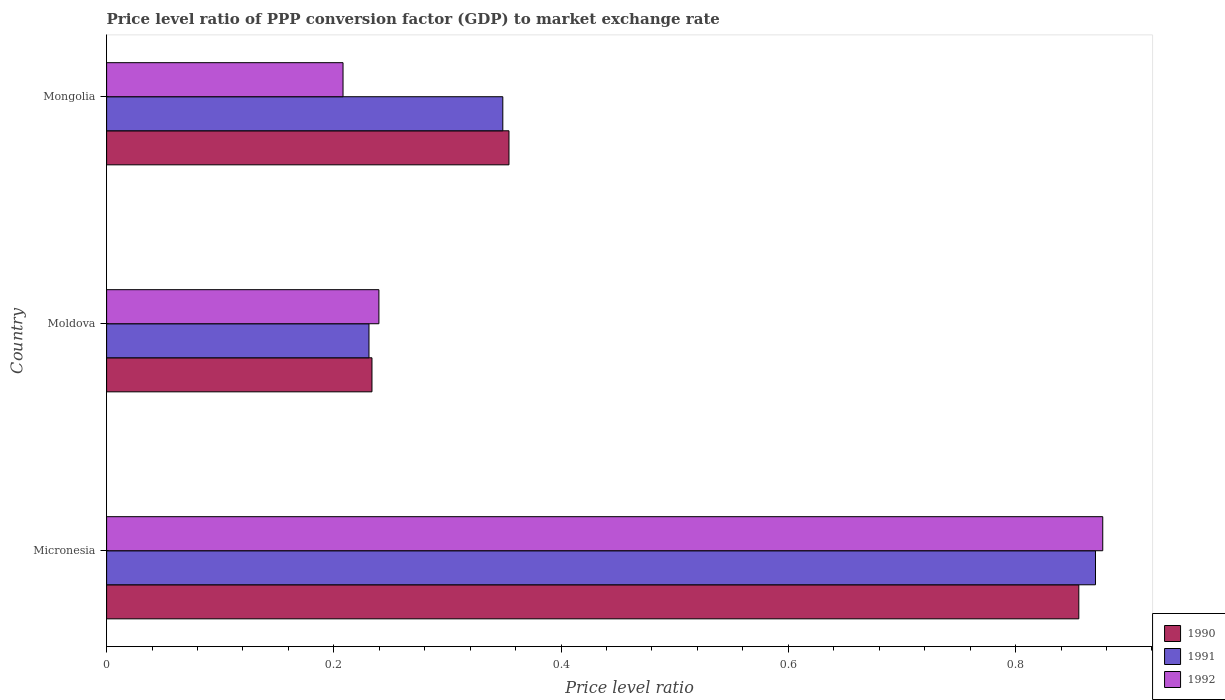How many different coloured bars are there?
Keep it short and to the point. 3. How many groups of bars are there?
Make the answer very short. 3. How many bars are there on the 3rd tick from the bottom?
Offer a very short reply. 3. What is the label of the 1st group of bars from the top?
Keep it short and to the point. Mongolia. In how many cases, is the number of bars for a given country not equal to the number of legend labels?
Your response must be concise. 0. What is the price level ratio in 1992 in Micronesia?
Provide a succinct answer. 0.88. Across all countries, what is the maximum price level ratio in 1992?
Keep it short and to the point. 0.88. Across all countries, what is the minimum price level ratio in 1992?
Your response must be concise. 0.21. In which country was the price level ratio in 1992 maximum?
Keep it short and to the point. Micronesia. In which country was the price level ratio in 1990 minimum?
Keep it short and to the point. Moldova. What is the total price level ratio in 1991 in the graph?
Offer a terse response. 1.45. What is the difference between the price level ratio in 1992 in Micronesia and that in Moldova?
Make the answer very short. 0.64. What is the difference between the price level ratio in 1990 in Moldova and the price level ratio in 1991 in Micronesia?
Keep it short and to the point. -0.64. What is the average price level ratio in 1990 per country?
Your answer should be very brief. 0.48. What is the difference between the price level ratio in 1990 and price level ratio in 1991 in Micronesia?
Provide a succinct answer. -0.01. What is the ratio of the price level ratio in 1990 in Micronesia to that in Mongolia?
Provide a succinct answer. 2.42. Is the price level ratio in 1990 in Micronesia less than that in Moldova?
Keep it short and to the point. No. Is the difference between the price level ratio in 1990 in Moldova and Mongolia greater than the difference between the price level ratio in 1991 in Moldova and Mongolia?
Make the answer very short. No. What is the difference between the highest and the second highest price level ratio in 1990?
Offer a terse response. 0.5. What is the difference between the highest and the lowest price level ratio in 1992?
Ensure brevity in your answer.  0.67. In how many countries, is the price level ratio in 1992 greater than the average price level ratio in 1992 taken over all countries?
Offer a terse response. 1. Is the sum of the price level ratio in 1992 in Micronesia and Mongolia greater than the maximum price level ratio in 1990 across all countries?
Your response must be concise. Yes. What does the 2nd bar from the top in Micronesia represents?
Offer a terse response. 1991. What does the 1st bar from the bottom in Moldova represents?
Offer a terse response. 1990. Is it the case that in every country, the sum of the price level ratio in 1990 and price level ratio in 1992 is greater than the price level ratio in 1991?
Offer a terse response. Yes. Are all the bars in the graph horizontal?
Keep it short and to the point. Yes. How many countries are there in the graph?
Provide a succinct answer. 3. What is the difference between two consecutive major ticks on the X-axis?
Make the answer very short. 0.2. Are the values on the major ticks of X-axis written in scientific E-notation?
Offer a very short reply. No. Does the graph contain grids?
Your response must be concise. No. How many legend labels are there?
Provide a short and direct response. 3. How are the legend labels stacked?
Provide a succinct answer. Vertical. What is the title of the graph?
Your response must be concise. Price level ratio of PPP conversion factor (GDP) to market exchange rate. Does "2011" appear as one of the legend labels in the graph?
Ensure brevity in your answer.  No. What is the label or title of the X-axis?
Offer a terse response. Price level ratio. What is the Price level ratio in 1990 in Micronesia?
Your response must be concise. 0.86. What is the Price level ratio of 1991 in Micronesia?
Offer a terse response. 0.87. What is the Price level ratio in 1992 in Micronesia?
Provide a succinct answer. 0.88. What is the Price level ratio of 1990 in Moldova?
Give a very brief answer. 0.23. What is the Price level ratio in 1991 in Moldova?
Your response must be concise. 0.23. What is the Price level ratio of 1992 in Moldova?
Provide a short and direct response. 0.24. What is the Price level ratio of 1990 in Mongolia?
Provide a short and direct response. 0.35. What is the Price level ratio in 1991 in Mongolia?
Keep it short and to the point. 0.35. What is the Price level ratio of 1992 in Mongolia?
Your answer should be compact. 0.21. Across all countries, what is the maximum Price level ratio in 1990?
Provide a short and direct response. 0.86. Across all countries, what is the maximum Price level ratio of 1991?
Make the answer very short. 0.87. Across all countries, what is the maximum Price level ratio of 1992?
Give a very brief answer. 0.88. Across all countries, what is the minimum Price level ratio of 1990?
Your answer should be compact. 0.23. Across all countries, what is the minimum Price level ratio of 1991?
Your response must be concise. 0.23. Across all countries, what is the minimum Price level ratio in 1992?
Provide a succinct answer. 0.21. What is the total Price level ratio in 1990 in the graph?
Provide a short and direct response. 1.44. What is the total Price level ratio of 1991 in the graph?
Provide a short and direct response. 1.45. What is the total Price level ratio in 1992 in the graph?
Offer a terse response. 1.32. What is the difference between the Price level ratio of 1990 in Micronesia and that in Moldova?
Provide a short and direct response. 0.62. What is the difference between the Price level ratio of 1991 in Micronesia and that in Moldova?
Offer a terse response. 0.64. What is the difference between the Price level ratio in 1992 in Micronesia and that in Moldova?
Give a very brief answer. 0.64. What is the difference between the Price level ratio of 1990 in Micronesia and that in Mongolia?
Provide a short and direct response. 0.5. What is the difference between the Price level ratio in 1991 in Micronesia and that in Mongolia?
Your answer should be very brief. 0.52. What is the difference between the Price level ratio in 1992 in Micronesia and that in Mongolia?
Your answer should be very brief. 0.67. What is the difference between the Price level ratio of 1990 in Moldova and that in Mongolia?
Make the answer very short. -0.12. What is the difference between the Price level ratio of 1991 in Moldova and that in Mongolia?
Provide a short and direct response. -0.12. What is the difference between the Price level ratio in 1992 in Moldova and that in Mongolia?
Give a very brief answer. 0.03. What is the difference between the Price level ratio of 1990 in Micronesia and the Price level ratio of 1991 in Moldova?
Keep it short and to the point. 0.62. What is the difference between the Price level ratio of 1990 in Micronesia and the Price level ratio of 1992 in Moldova?
Ensure brevity in your answer.  0.62. What is the difference between the Price level ratio of 1991 in Micronesia and the Price level ratio of 1992 in Moldova?
Make the answer very short. 0.63. What is the difference between the Price level ratio of 1990 in Micronesia and the Price level ratio of 1991 in Mongolia?
Make the answer very short. 0.51. What is the difference between the Price level ratio of 1990 in Micronesia and the Price level ratio of 1992 in Mongolia?
Ensure brevity in your answer.  0.65. What is the difference between the Price level ratio in 1991 in Micronesia and the Price level ratio in 1992 in Mongolia?
Provide a short and direct response. 0.66. What is the difference between the Price level ratio in 1990 in Moldova and the Price level ratio in 1991 in Mongolia?
Your response must be concise. -0.12. What is the difference between the Price level ratio of 1990 in Moldova and the Price level ratio of 1992 in Mongolia?
Your response must be concise. 0.03. What is the difference between the Price level ratio of 1991 in Moldova and the Price level ratio of 1992 in Mongolia?
Provide a succinct answer. 0.02. What is the average Price level ratio of 1990 per country?
Your answer should be very brief. 0.48. What is the average Price level ratio of 1991 per country?
Your response must be concise. 0.48. What is the average Price level ratio in 1992 per country?
Give a very brief answer. 0.44. What is the difference between the Price level ratio of 1990 and Price level ratio of 1991 in Micronesia?
Offer a terse response. -0.01. What is the difference between the Price level ratio of 1990 and Price level ratio of 1992 in Micronesia?
Your response must be concise. -0.02. What is the difference between the Price level ratio of 1991 and Price level ratio of 1992 in Micronesia?
Keep it short and to the point. -0.01. What is the difference between the Price level ratio in 1990 and Price level ratio in 1991 in Moldova?
Your answer should be compact. 0. What is the difference between the Price level ratio in 1990 and Price level ratio in 1992 in Moldova?
Keep it short and to the point. -0.01. What is the difference between the Price level ratio of 1991 and Price level ratio of 1992 in Moldova?
Your answer should be very brief. -0.01. What is the difference between the Price level ratio in 1990 and Price level ratio in 1991 in Mongolia?
Offer a very short reply. 0.01. What is the difference between the Price level ratio in 1990 and Price level ratio in 1992 in Mongolia?
Offer a terse response. 0.15. What is the difference between the Price level ratio in 1991 and Price level ratio in 1992 in Mongolia?
Make the answer very short. 0.14. What is the ratio of the Price level ratio in 1990 in Micronesia to that in Moldova?
Keep it short and to the point. 3.66. What is the ratio of the Price level ratio in 1991 in Micronesia to that in Moldova?
Your answer should be compact. 3.77. What is the ratio of the Price level ratio of 1992 in Micronesia to that in Moldova?
Your response must be concise. 3.66. What is the ratio of the Price level ratio of 1990 in Micronesia to that in Mongolia?
Provide a short and direct response. 2.42. What is the ratio of the Price level ratio of 1991 in Micronesia to that in Mongolia?
Provide a succinct answer. 2.5. What is the ratio of the Price level ratio of 1992 in Micronesia to that in Mongolia?
Give a very brief answer. 4.21. What is the ratio of the Price level ratio in 1990 in Moldova to that in Mongolia?
Offer a terse response. 0.66. What is the ratio of the Price level ratio of 1991 in Moldova to that in Mongolia?
Provide a succinct answer. 0.66. What is the ratio of the Price level ratio in 1992 in Moldova to that in Mongolia?
Your answer should be very brief. 1.15. What is the difference between the highest and the second highest Price level ratio of 1990?
Offer a terse response. 0.5. What is the difference between the highest and the second highest Price level ratio of 1991?
Keep it short and to the point. 0.52. What is the difference between the highest and the second highest Price level ratio of 1992?
Keep it short and to the point. 0.64. What is the difference between the highest and the lowest Price level ratio in 1990?
Give a very brief answer. 0.62. What is the difference between the highest and the lowest Price level ratio of 1991?
Your response must be concise. 0.64. What is the difference between the highest and the lowest Price level ratio in 1992?
Ensure brevity in your answer.  0.67. 